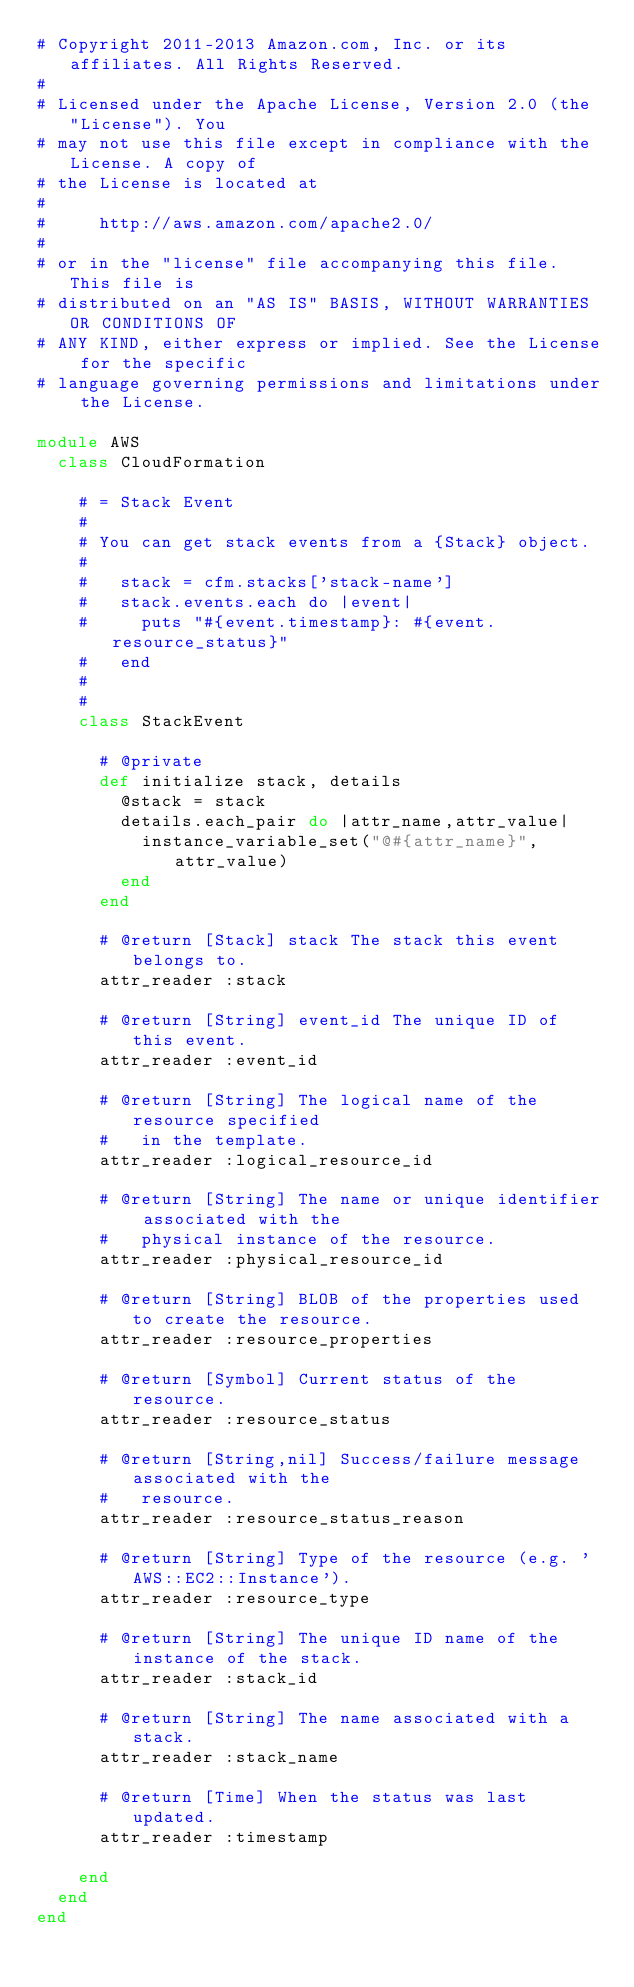Convert code to text. <code><loc_0><loc_0><loc_500><loc_500><_Ruby_># Copyright 2011-2013 Amazon.com, Inc. or its affiliates. All Rights Reserved.
#
# Licensed under the Apache License, Version 2.0 (the "License"). You
# may not use this file except in compliance with the License. A copy of
# the License is located at
#
#     http://aws.amazon.com/apache2.0/
#
# or in the "license" file accompanying this file. This file is
# distributed on an "AS IS" BASIS, WITHOUT WARRANTIES OR CONDITIONS OF
# ANY KIND, either express or implied. See the License for the specific
# language governing permissions and limitations under the License.

module AWS
  class CloudFormation

    # = Stack Event
    #
    # You can get stack events from a {Stack} object.
    #
    #   stack = cfm.stacks['stack-name']
    #   stack.events.each do |event|
    #     puts "#{event.timestamp}: #{event.resource_status}"
    #   end
    #
    #
    class StackEvent

      # @private
      def initialize stack, details
        @stack = stack
        details.each_pair do |attr_name,attr_value|
          instance_variable_set("@#{attr_name}", attr_value)
        end
      end

      # @return [Stack] stack The stack this event belongs to.
      attr_reader :stack

      # @return [String] event_id The unique ID of this event.
      attr_reader :event_id

      # @return [String] The logical name of the resource specified 
      #   in the template.
      attr_reader :logical_resource_id

      # @return [String] The name or unique identifier associated with the 
      #   physical instance of the resource.
      attr_reader :physical_resource_id

      # @return [String] BLOB of the properties used to create the resource.
      attr_reader :resource_properties

      # @return [Symbol] Current status of the resource.  
      attr_reader :resource_status

      # @return [String,nil] Success/failure message associated with the 
      #   resource.
      attr_reader :resource_status_reason

      # @return [String] Type of the resource (e.g. 'AWS::EC2::Instance').
      attr_reader :resource_type

      # @return [String] The unique ID name of the instance of the stack.
      attr_reader :stack_id

      # @return [String] The name associated with a stack.
      attr_reader :stack_name

      # @return [Time] When the status was last updated.
      attr_reader :timestamp

    end
  end
end
</code> 